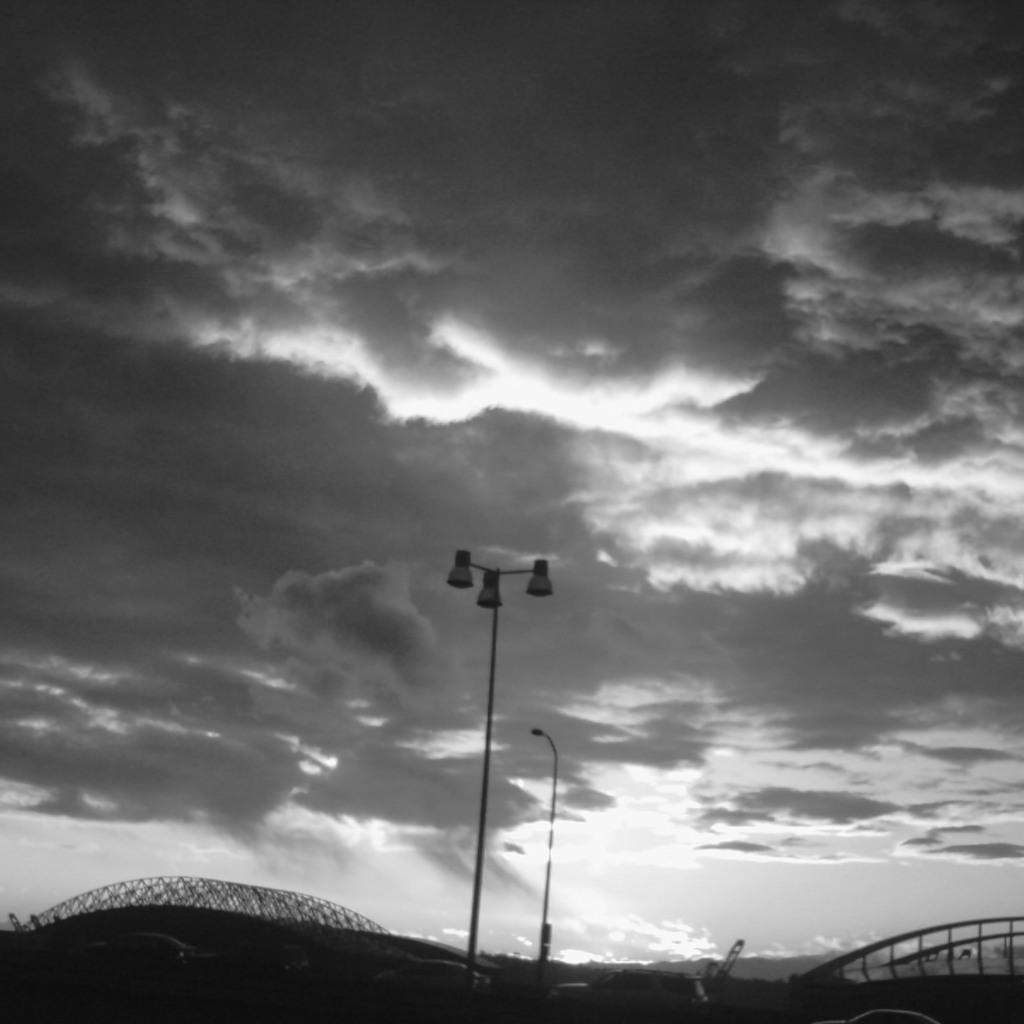What is the color scheme of the image? The image is black and white. What types of vehicles are in the image? There are vehicles in the image. What structure can be seen behind the vehicles? There is a bridge visible behind the vehicles. What else can be seen in the image besides the vehicles and bridge? There are poles in the image. What is visible in the background of the image? The sky is visible in the background of the image, and clouds are present. What type of seed is being planted by the girl in the image? There is no girl or seed present in the image. What function does the calculator serve in the image? There is no calculator present in the image. 